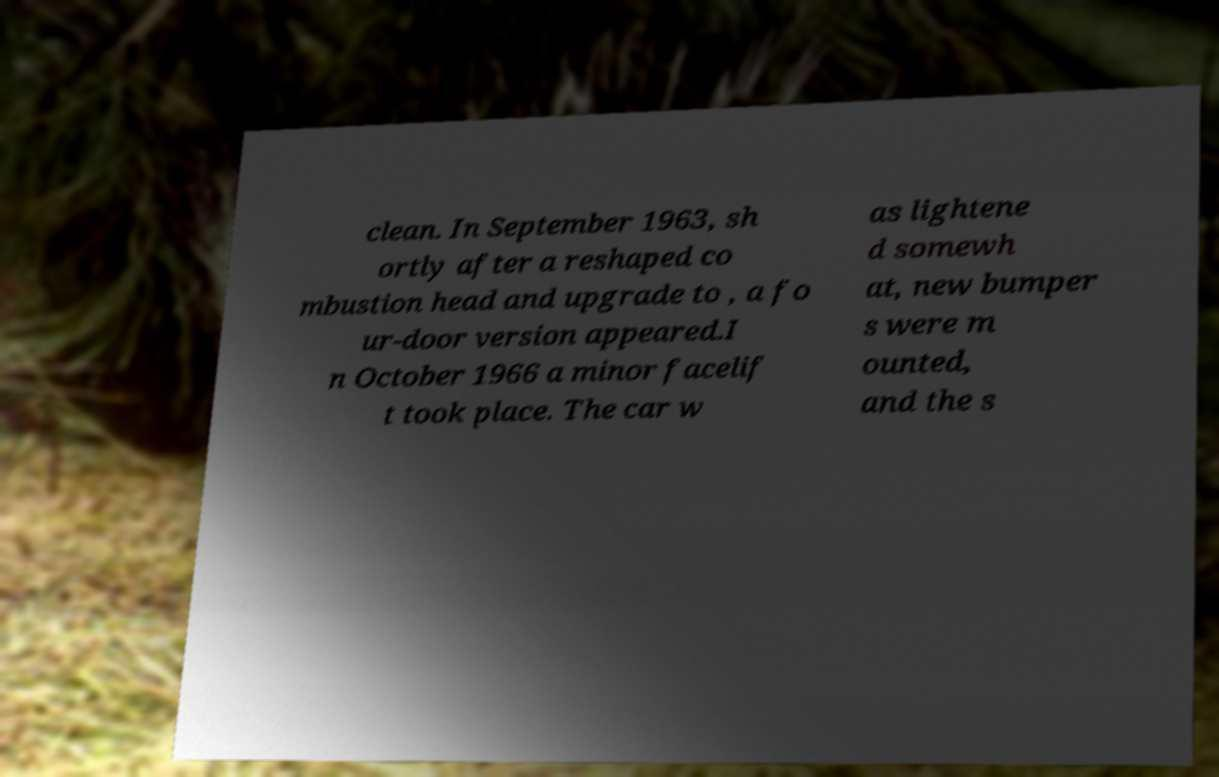Please identify and transcribe the text found in this image. clean. In September 1963, sh ortly after a reshaped co mbustion head and upgrade to , a fo ur-door version appeared.I n October 1966 a minor facelif t took place. The car w as lightene d somewh at, new bumper s were m ounted, and the s 